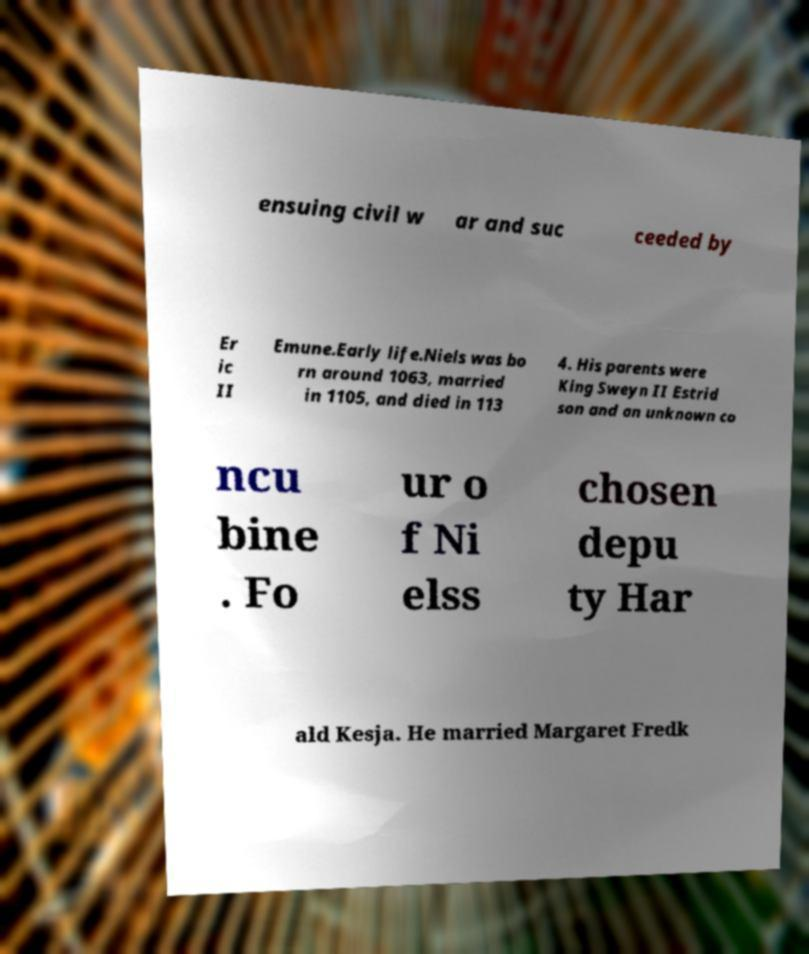For documentation purposes, I need the text within this image transcribed. Could you provide that? ensuing civil w ar and suc ceeded by Er ic II Emune.Early life.Niels was bo rn around 1063, married in 1105, and died in 113 4. His parents were King Sweyn II Estrid son and an unknown co ncu bine . Fo ur o f Ni elss chosen depu ty Har ald Kesja. He married Margaret Fredk 